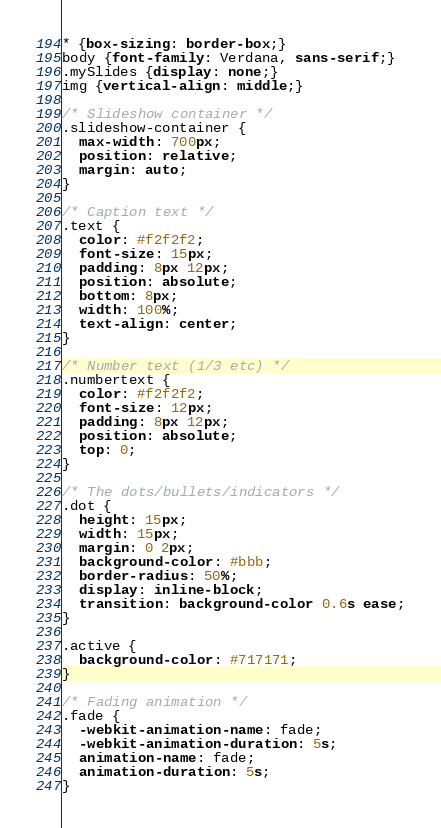Convert code to text. <code><loc_0><loc_0><loc_500><loc_500><_CSS_>* {box-sizing: border-box;}
body {font-family: Verdana, sans-serif;}
.mySlides {display: none;}
img {vertical-align: middle;}

/* Slideshow container */
.slideshow-container {
  max-width: 700px;
  position: relative;
  margin: auto;
}

/* Caption text */
.text {
  color: #f2f2f2;
  font-size: 15px;
  padding: 8px 12px;
  position: absolute;
  bottom: 8px;
  width: 100%;
  text-align: center;
}

/* Number text (1/3 etc) */
.numbertext {
  color: #f2f2f2;
  font-size: 12px;
  padding: 8px 12px;
  position: absolute;
  top: 0;
}

/* The dots/bullets/indicators */
.dot {
  height: 15px;
  width: 15px;
  margin: 0 2px;
  background-color: #bbb;
  border-radius: 50%;
  display: inline-block;
  transition: background-color 0.6s ease;
}

.active {
  background-color: #717171;
}

/* Fading animation */
.fade {
  -webkit-animation-name: fade;
  -webkit-animation-duration: 5s;
  animation-name: fade;
  animation-duration: 5s;
}
</code> 